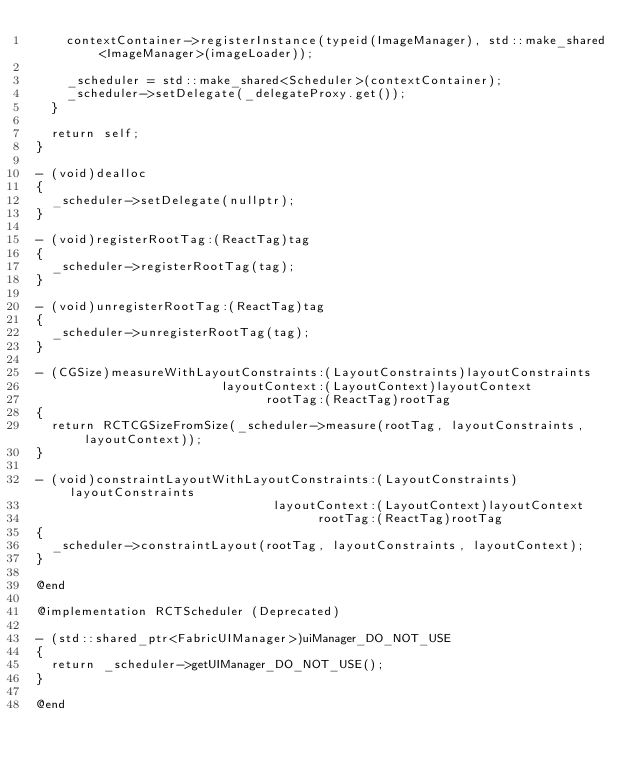<code> <loc_0><loc_0><loc_500><loc_500><_ObjectiveC_>    contextContainer->registerInstance(typeid(ImageManager), std::make_shared<ImageManager>(imageLoader));

    _scheduler = std::make_shared<Scheduler>(contextContainer);
    _scheduler->setDelegate(_delegateProxy.get());
  }

  return self;
}

- (void)dealloc
{
  _scheduler->setDelegate(nullptr);
}

- (void)registerRootTag:(ReactTag)tag
{
  _scheduler->registerRootTag(tag);
}

- (void)unregisterRootTag:(ReactTag)tag
{
  _scheduler->unregisterRootTag(tag);
}

- (CGSize)measureWithLayoutConstraints:(LayoutConstraints)layoutConstraints
                         layoutContext:(LayoutContext)layoutContext
                               rootTag:(ReactTag)rootTag
{
  return RCTCGSizeFromSize(_scheduler->measure(rootTag, layoutConstraints, layoutContext));
}

- (void)constraintLayoutWithLayoutConstraints:(LayoutConstraints)layoutConstraints
                                layoutContext:(LayoutContext)layoutContext
                                      rootTag:(ReactTag)rootTag
{
  _scheduler->constraintLayout(rootTag, layoutConstraints, layoutContext);
}

@end

@implementation RCTScheduler (Deprecated)

- (std::shared_ptr<FabricUIManager>)uiManager_DO_NOT_USE
{
  return _scheduler->getUIManager_DO_NOT_USE();
}

@end
</code> 